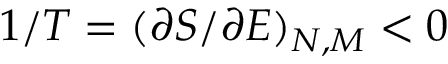<formula> <loc_0><loc_0><loc_500><loc_500>1 / T = ( \partial S / \partial E ) _ { N , M } < 0</formula> 